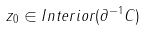Convert formula to latex. <formula><loc_0><loc_0><loc_500><loc_500>z _ { 0 } \in I n t e r i o r ( \partial ^ { - 1 } C )</formula> 